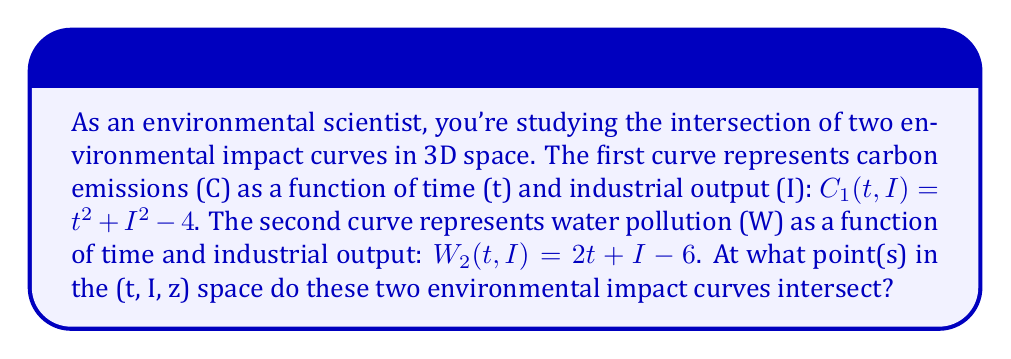Solve this math problem. To find the intersection of these two curves in 3D space, we need to set their equations equal to each other and solve for t and I:

1) Set the equations equal:
   $$t^2 + I^2 - 4 = 2t + I - 6$$

2) Rearrange the equation:
   $$t^2 + I^2 - 2t - I + 2 = 0$$

3) Complete the square for t:
   $$(t^2 - 2t + 1) + I^2 - I + 1 = 0$$
   $$(t - 1)^2 + I^2 - I + 1 = 0$$

4) Complete the square for I:
   $$(t - 1)^2 + (I^2 - I + \frac{1}{4}) + \frac{3}{4} = 0$$
   $$(t - 1)^2 + (I - \frac{1}{2})^2 = -\frac{3}{4}$$

5) This equation represents a circle in the t-I plane. However, the right-hand side is negative, which means there are no real solutions.

6) Therefore, the two curves do not intersect in real 3D space.
Answer: The curves do not intersect in real 3D space. 